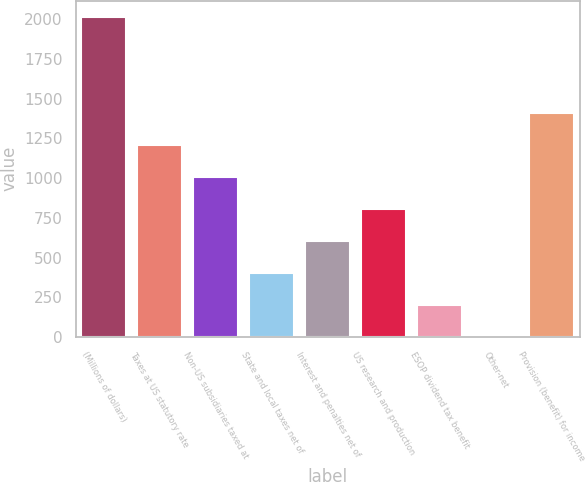Convert chart to OTSL. <chart><loc_0><loc_0><loc_500><loc_500><bar_chart><fcel>(Millions of dollars)<fcel>Taxes at US statutory rate<fcel>Non-US subsidiaries taxed at<fcel>State and local taxes net of<fcel>Interest and penalties net of<fcel>US research and production<fcel>ESOP dividend tax benefit<fcel>Other-net<fcel>Provision (benefit) for income<nl><fcel>2017<fcel>1210.32<fcel>1008.65<fcel>403.64<fcel>605.31<fcel>806.98<fcel>201.97<fcel>0.3<fcel>1411.99<nl></chart> 